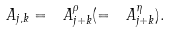Convert formula to latex. <formula><loc_0><loc_0><loc_500><loc_500>\ A _ { j , k } = \ A _ { j + k } ^ { \rho } ( = \ A _ { j + k } ^ { \eta } ) .</formula> 